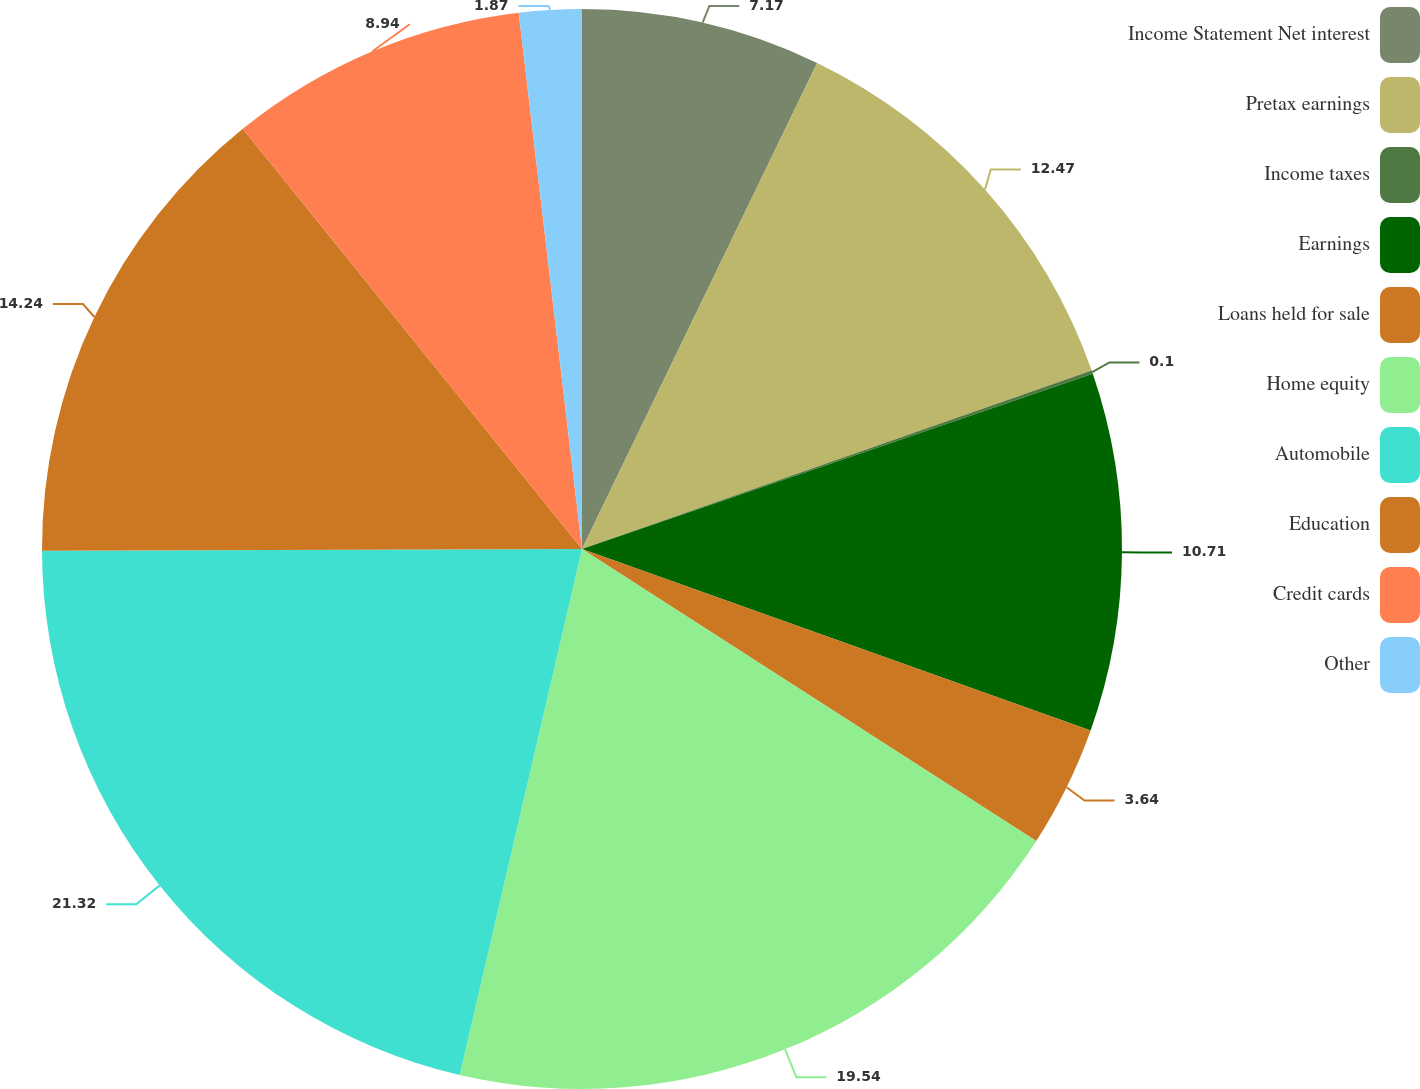<chart> <loc_0><loc_0><loc_500><loc_500><pie_chart><fcel>Income Statement Net interest<fcel>Pretax earnings<fcel>Income taxes<fcel>Earnings<fcel>Loans held for sale<fcel>Home equity<fcel>Automobile<fcel>Education<fcel>Credit cards<fcel>Other<nl><fcel>7.17%<fcel>12.47%<fcel>0.1%<fcel>10.71%<fcel>3.64%<fcel>19.54%<fcel>21.31%<fcel>14.24%<fcel>8.94%<fcel>1.87%<nl></chart> 